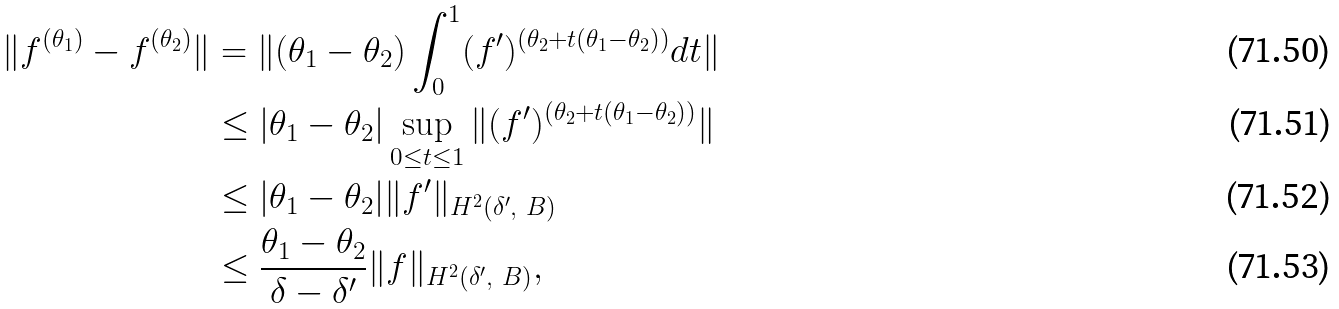Convert formula to latex. <formula><loc_0><loc_0><loc_500><loc_500>\| f ^ { ( \theta _ { 1 } ) } - f ^ { ( \theta _ { 2 } ) } \| & = \| ( \theta _ { 1 } - \theta _ { 2 } ) \int _ { 0 } ^ { 1 } ( f ^ { \prime } ) ^ { ( \theta _ { 2 } + t ( \theta _ { 1 } - \theta _ { 2 } ) ) } d t \| \\ & \leq | \theta _ { 1 } - \theta _ { 2 } | \sup _ { 0 \leq t \leq 1 } \| ( f ^ { \prime } ) ^ { ( \theta _ { 2 } + t ( \theta _ { 1 } - \theta _ { 2 } ) ) } \| \\ & \leq | \theta _ { 1 } - \theta _ { 2 } | \| f ^ { \prime } \| _ { H ^ { 2 } ( \delta ^ { \prime } , \ B ) } \\ & \leq \frac { \theta _ { 1 } - \theta _ { 2 } } { \delta - \delta ^ { \prime } } \| f \| _ { H ^ { 2 } ( \delta ^ { \prime } , \ B ) } ,</formula> 